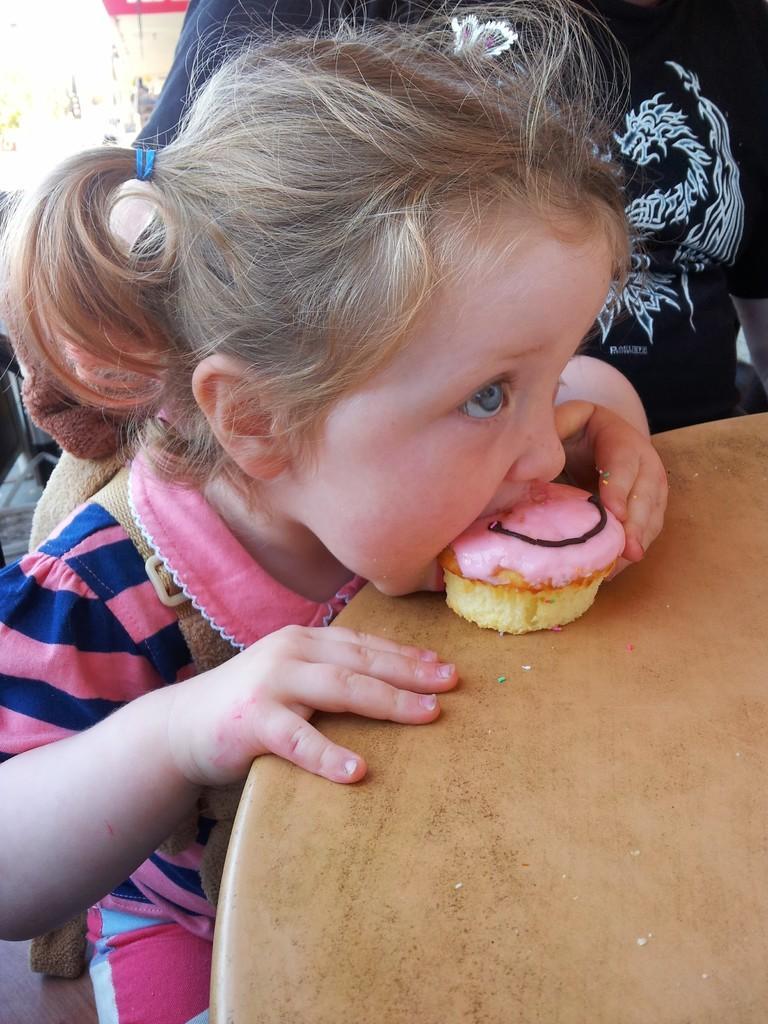Describe this image in one or two sentences. In this picture there is a girl who is wearing pink color dress. She is eating cupcake. On the table we can see the cupcake. Beside her there is a person who is wearing black dress. On the top left background we can see shed, trees and poles. 